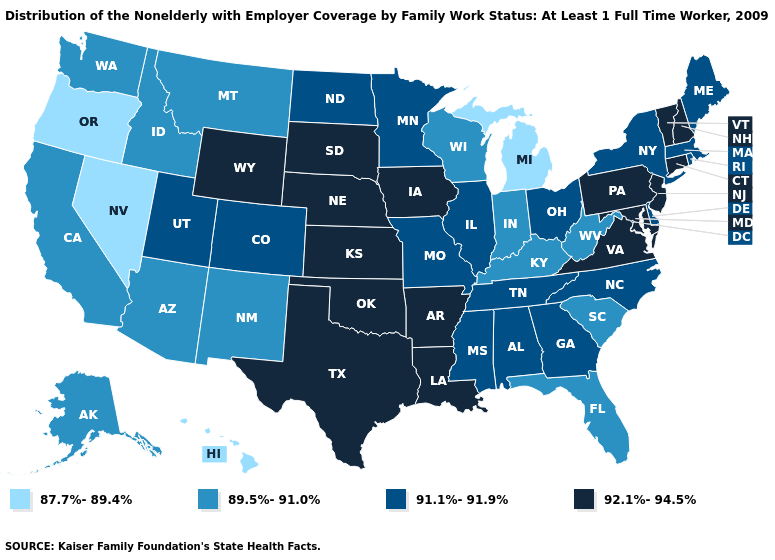Does South Carolina have a lower value than New Mexico?
Keep it brief. No. What is the value of New Hampshire?
Answer briefly. 92.1%-94.5%. Name the states that have a value in the range 92.1%-94.5%?
Short answer required. Arkansas, Connecticut, Iowa, Kansas, Louisiana, Maryland, Nebraska, New Hampshire, New Jersey, Oklahoma, Pennsylvania, South Dakota, Texas, Vermont, Virginia, Wyoming. Among the states that border Mississippi , which have the lowest value?
Concise answer only. Alabama, Tennessee. What is the highest value in the USA?
Write a very short answer. 92.1%-94.5%. Which states have the lowest value in the USA?
Be succinct. Hawaii, Michigan, Nevada, Oregon. What is the value of Delaware?
Short answer required. 91.1%-91.9%. Which states have the highest value in the USA?
Write a very short answer. Arkansas, Connecticut, Iowa, Kansas, Louisiana, Maryland, Nebraska, New Hampshire, New Jersey, Oklahoma, Pennsylvania, South Dakota, Texas, Vermont, Virginia, Wyoming. What is the value of Iowa?
Concise answer only. 92.1%-94.5%. What is the value of Nebraska?
Give a very brief answer. 92.1%-94.5%. Name the states that have a value in the range 91.1%-91.9%?
Be succinct. Alabama, Colorado, Delaware, Georgia, Illinois, Maine, Massachusetts, Minnesota, Mississippi, Missouri, New York, North Carolina, North Dakota, Ohio, Rhode Island, Tennessee, Utah. Name the states that have a value in the range 87.7%-89.4%?
Give a very brief answer. Hawaii, Michigan, Nevada, Oregon. What is the value of New Hampshire?
Short answer required. 92.1%-94.5%. Does Minnesota have the lowest value in the USA?
Short answer required. No. Name the states that have a value in the range 87.7%-89.4%?
Be succinct. Hawaii, Michigan, Nevada, Oregon. 